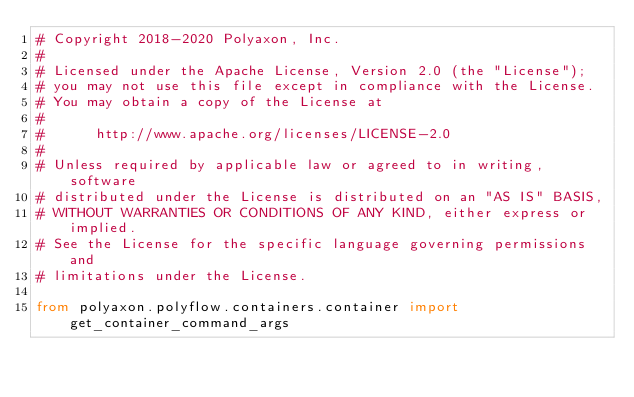Convert code to text. <code><loc_0><loc_0><loc_500><loc_500><_Python_># Copyright 2018-2020 Polyaxon, Inc.
#
# Licensed under the Apache License, Version 2.0 (the "License");
# you may not use this file except in compliance with the License.
# You may obtain a copy of the License at
#
#      http://www.apache.org/licenses/LICENSE-2.0
#
# Unless required by applicable law or agreed to in writing, software
# distributed under the License is distributed on an "AS IS" BASIS,
# WITHOUT WARRANTIES OR CONDITIONS OF ANY KIND, either express or implied.
# See the License for the specific language governing permissions and
# limitations under the License.

from polyaxon.polyflow.containers.container import get_container_command_args
</code> 